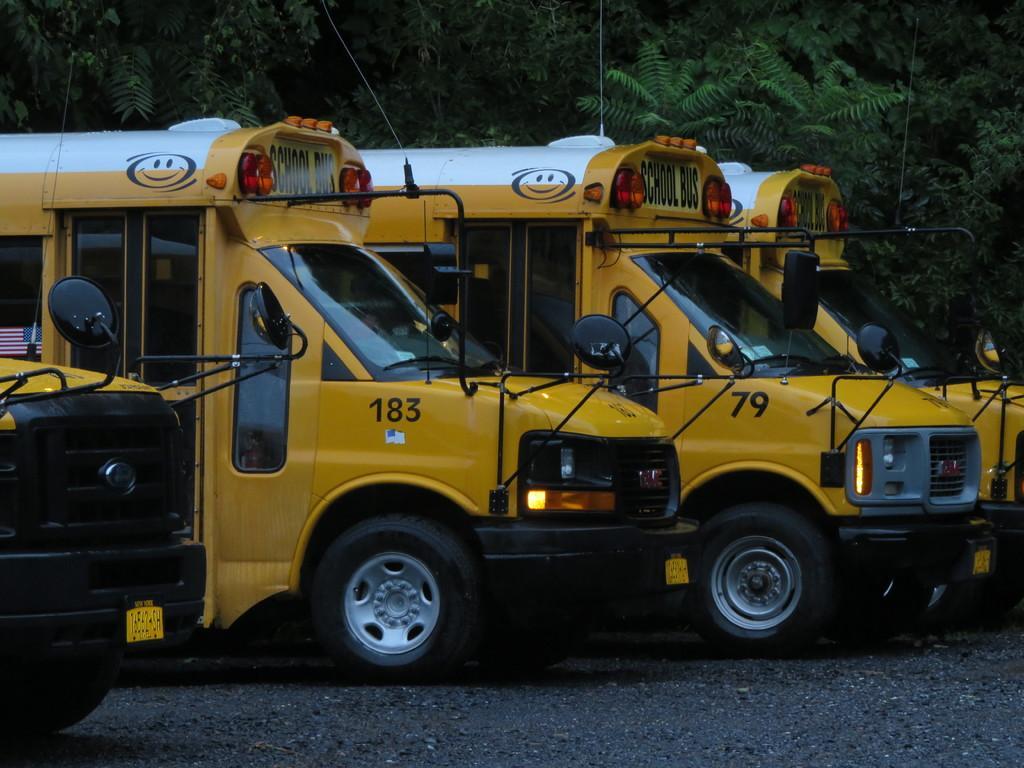Could you give a brief overview of what you see in this image? In the background we can see the trees. In this picture we can see the school buses parked on the road. 